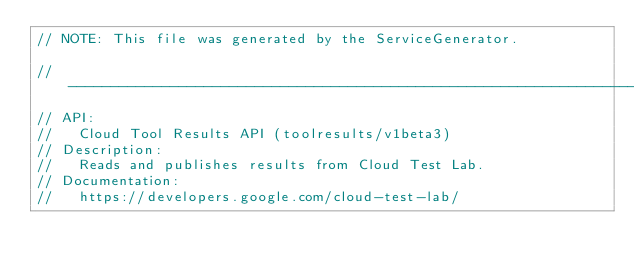Convert code to text. <code><loc_0><loc_0><loc_500><loc_500><_C_>// NOTE: This file was generated by the ServiceGenerator.

// ----------------------------------------------------------------------------
// API:
//   Cloud Tool Results API (toolresults/v1beta3)
// Description:
//   Reads and publishes results from Cloud Test Lab.
// Documentation:
//   https://developers.google.com/cloud-test-lab/
</code> 